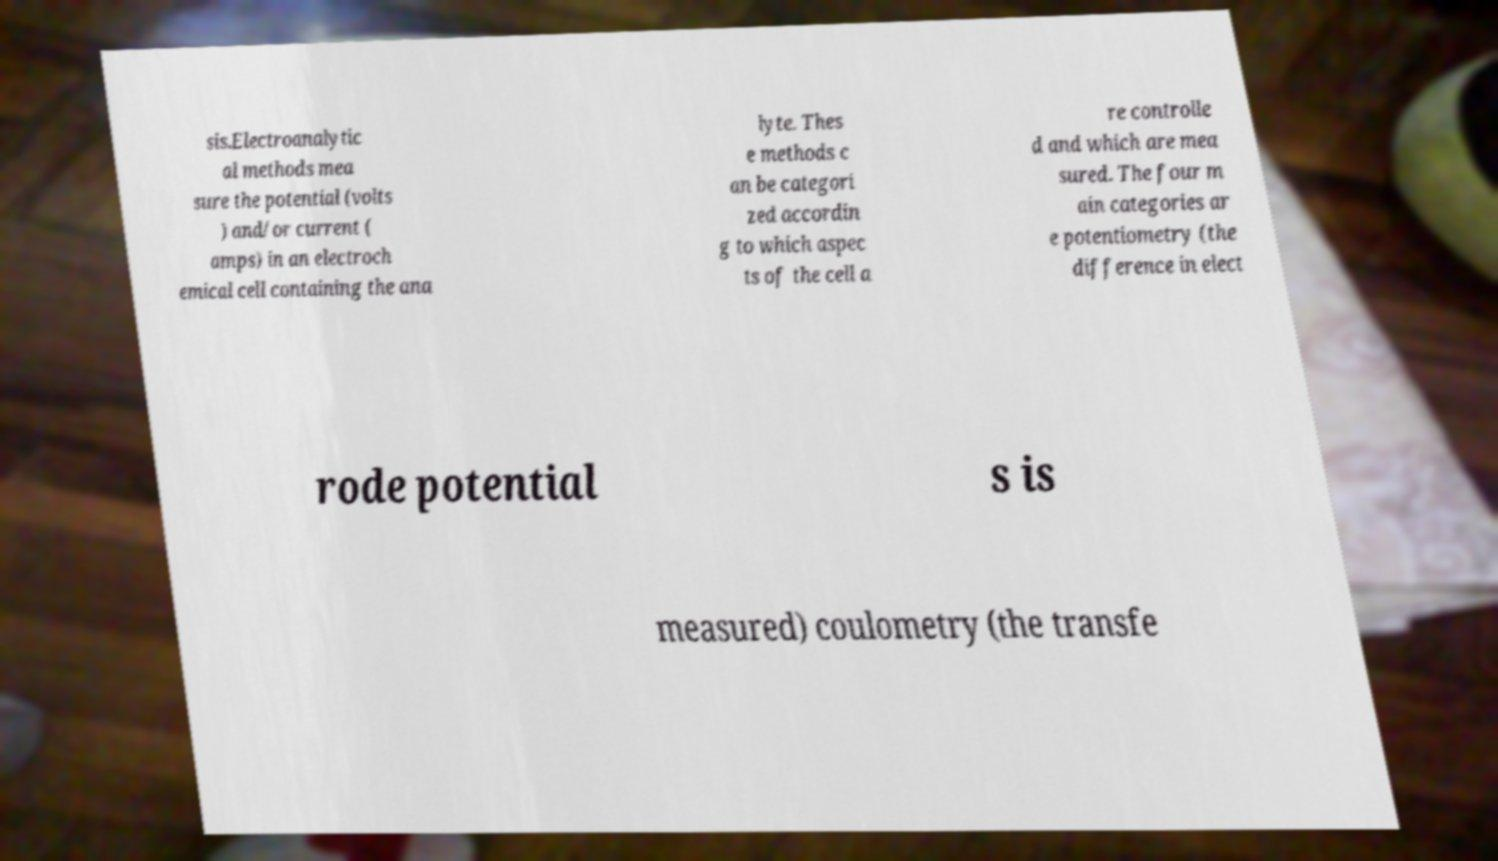There's text embedded in this image that I need extracted. Can you transcribe it verbatim? sis.Electroanalytic al methods mea sure the potential (volts ) and/or current ( amps) in an electroch emical cell containing the ana lyte. Thes e methods c an be categori zed accordin g to which aspec ts of the cell a re controlle d and which are mea sured. The four m ain categories ar e potentiometry (the difference in elect rode potential s is measured) coulometry (the transfe 